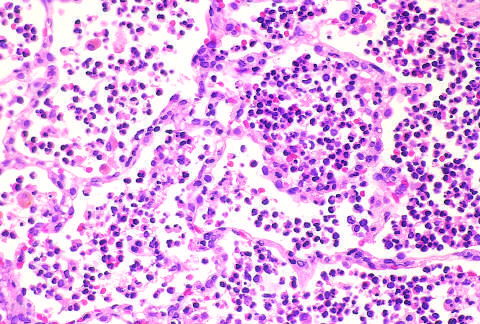what correspond to early red hepatization?
Answer the question using a single word or phrase. The congested septal capillaries and extensive neutrophil exudation into alveoli 